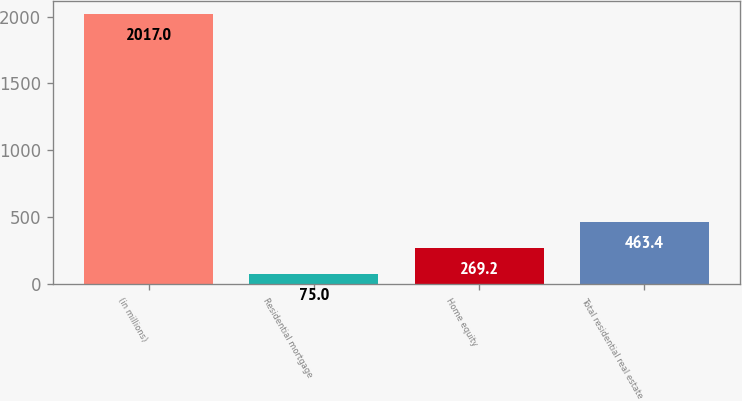Convert chart to OTSL. <chart><loc_0><loc_0><loc_500><loc_500><bar_chart><fcel>(in millions)<fcel>Residential mortgage<fcel>Home equity<fcel>Total residential real estate<nl><fcel>2017<fcel>75<fcel>269.2<fcel>463.4<nl></chart> 